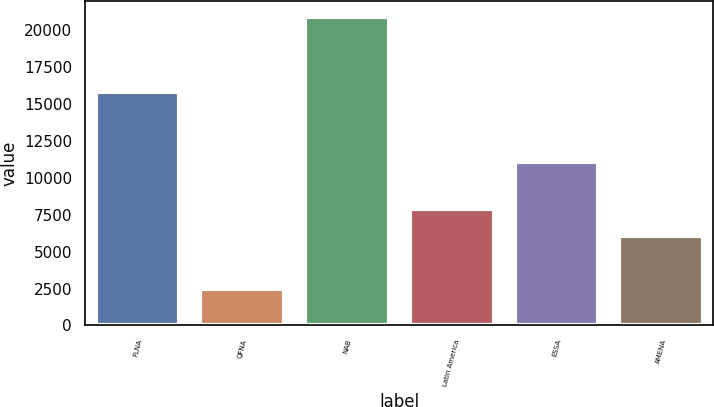Convert chart. <chart><loc_0><loc_0><loc_500><loc_500><bar_chart><fcel>FLNA<fcel>QFNA<fcel>NAB<fcel>Latin America<fcel>ESSA<fcel>AMENA<nl><fcel>15798<fcel>2503<fcel>20936<fcel>7873.3<fcel>11050<fcel>6030<nl></chart> 